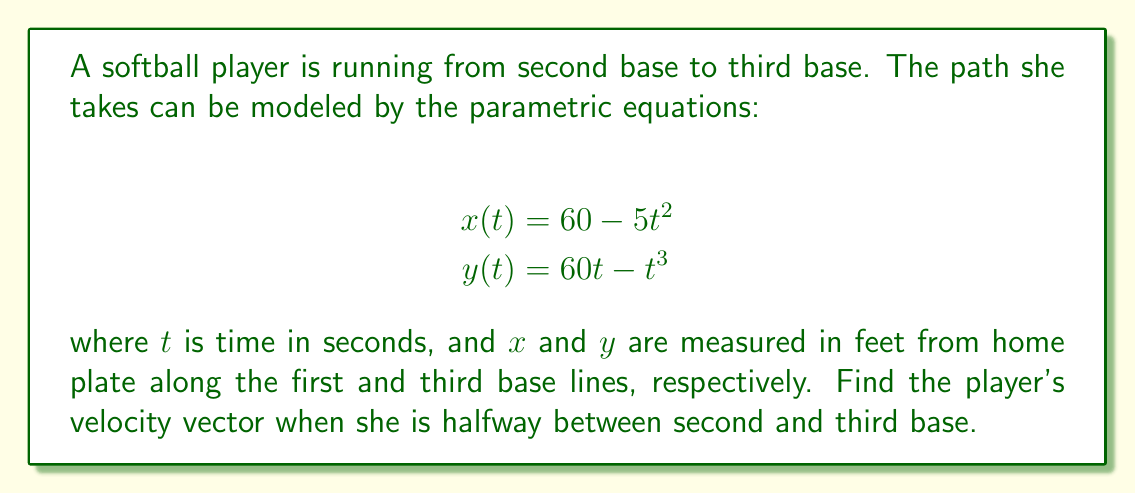Give your solution to this math problem. To solve this problem, we'll follow these steps:

1) First, we need to find the coordinates of second and third base:
   - Second base: (60, 60)
   - Third base: (0, 60)

2) The midpoint between these bases is (30, 60).

3) To find the velocity vector, we need to differentiate x(t) and y(t) with respect to t:
   $$\frac{dx}{dt} = -10t$$
   $$\frac{dy}{dt} = 60 - 3t^2$$

4) The velocity vector is given by $\vec{v}(t) = \langle \frac{dx}{dt}, \frac{dy}{dt} \rangle = \langle -10t, 60 - 3t^2 \rangle$

5) Now, we need to find the value of t when the player is at (30, 60). We can use the x-equation:
   $$30 = 60 - 5t^2$$
   $$5t^2 = 30$$
   $$t^2 = 6$$
   $$t = \sqrt{6} \approx 2.45 \text{ seconds}$$

6) Substituting this value of t into our velocity vector:
   $$\vec{v}(\sqrt{6}) = \langle -10\sqrt{6}, 60 - 3(\sqrt{6})^2 \rangle$$
   $$= \langle -10\sqrt{6}, 60 - 18 \rangle$$
   $$= \langle -10\sqrt{6}, 42 \rangle$$

7) This vector represents the player's instantaneous velocity when she's halfway between second and third base.
Answer: The player's velocity vector when she is halfway between second and third base is $\langle -10\sqrt{6}, 42 \rangle$ feet per second. 